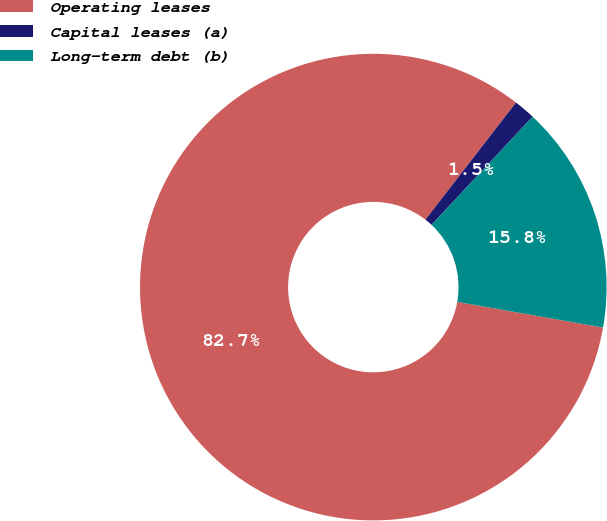Convert chart. <chart><loc_0><loc_0><loc_500><loc_500><pie_chart><fcel>Operating leases<fcel>Capital leases (a)<fcel>Long-term debt (b)<nl><fcel>82.7%<fcel>1.49%<fcel>15.81%<nl></chart> 